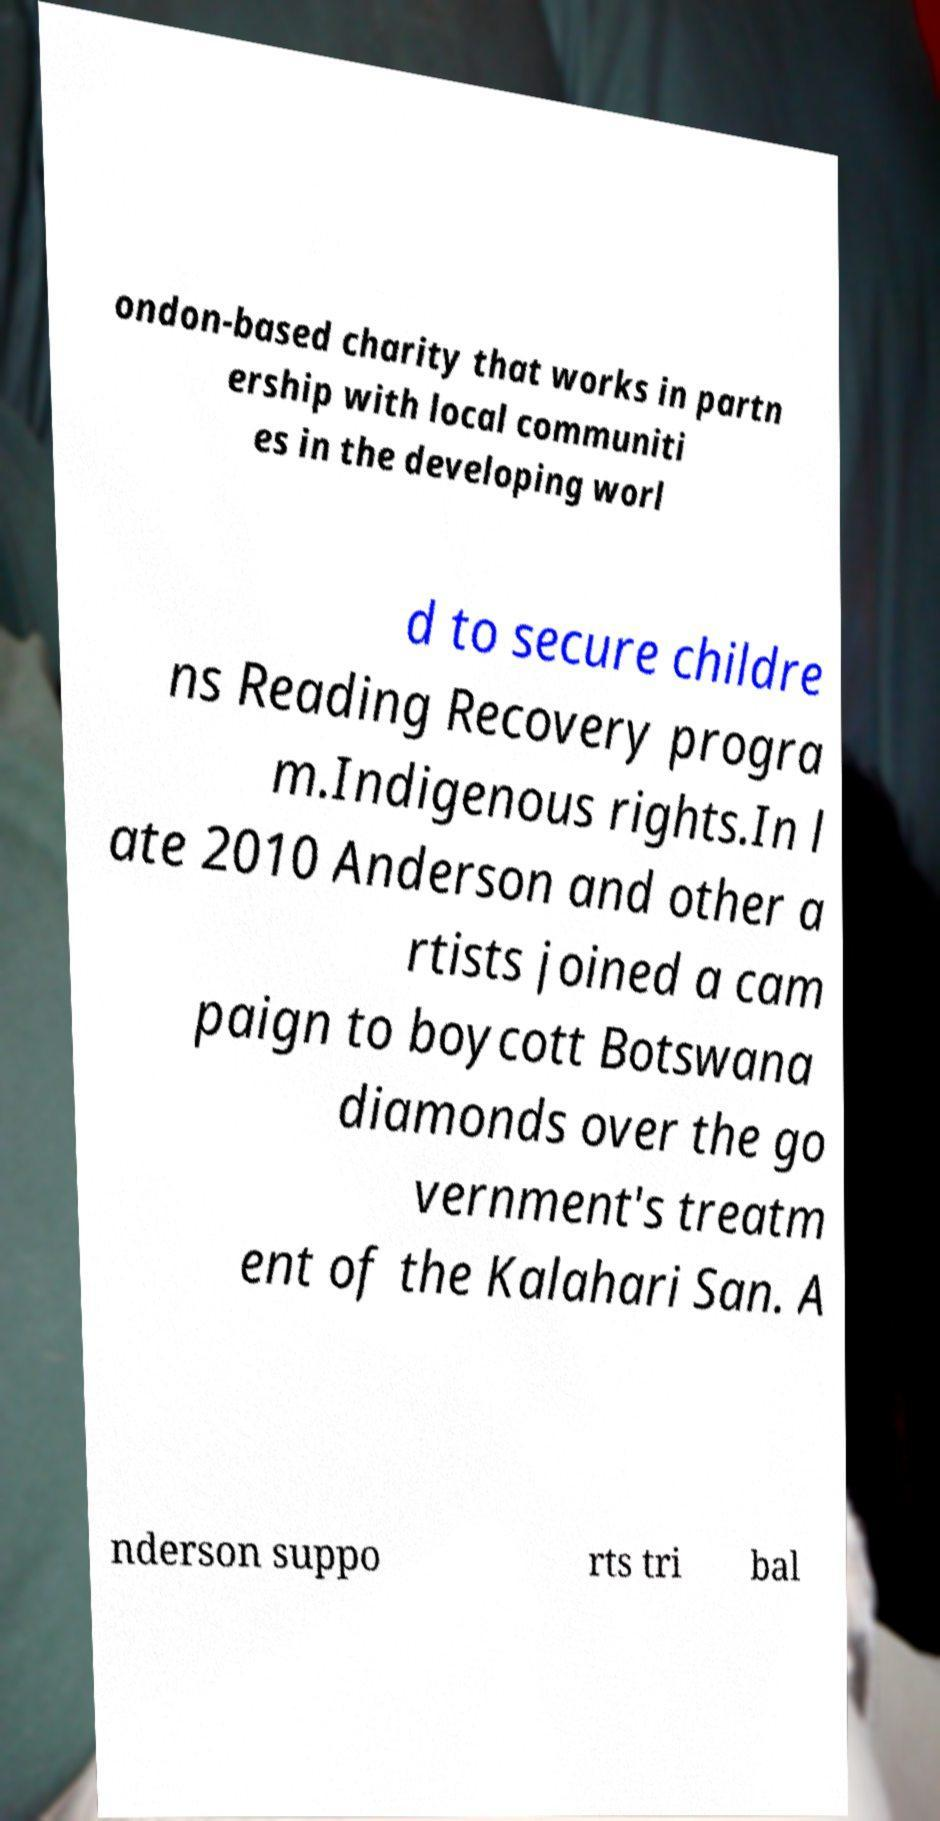Could you extract and type out the text from this image? ondon-based charity that works in partn ership with local communiti es in the developing worl d to secure childre ns Reading Recovery progra m.Indigenous rights.In l ate 2010 Anderson and other a rtists joined a cam paign to boycott Botswana diamonds over the go vernment's treatm ent of the Kalahari San. A nderson suppo rts tri bal 